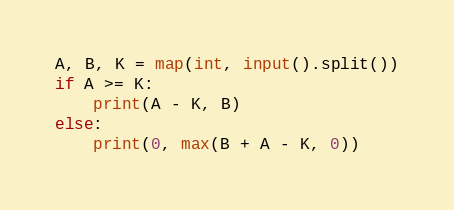<code> <loc_0><loc_0><loc_500><loc_500><_Python_>A, B, K = map(int, input().split())
if A >= K:
    print(A - K, B)
else:
    print(0, max(B + A - K, 0))</code> 